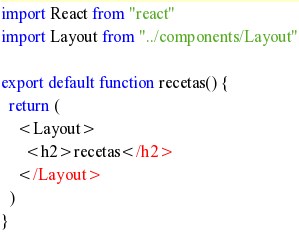<code> <loc_0><loc_0><loc_500><loc_500><_JavaScript_>import React from "react"
import Layout from "../components/Layout"

export default function recetas() {
  return (
    <Layout>
      <h2>recetas</h2>
    </Layout>
  )
}
</code> 